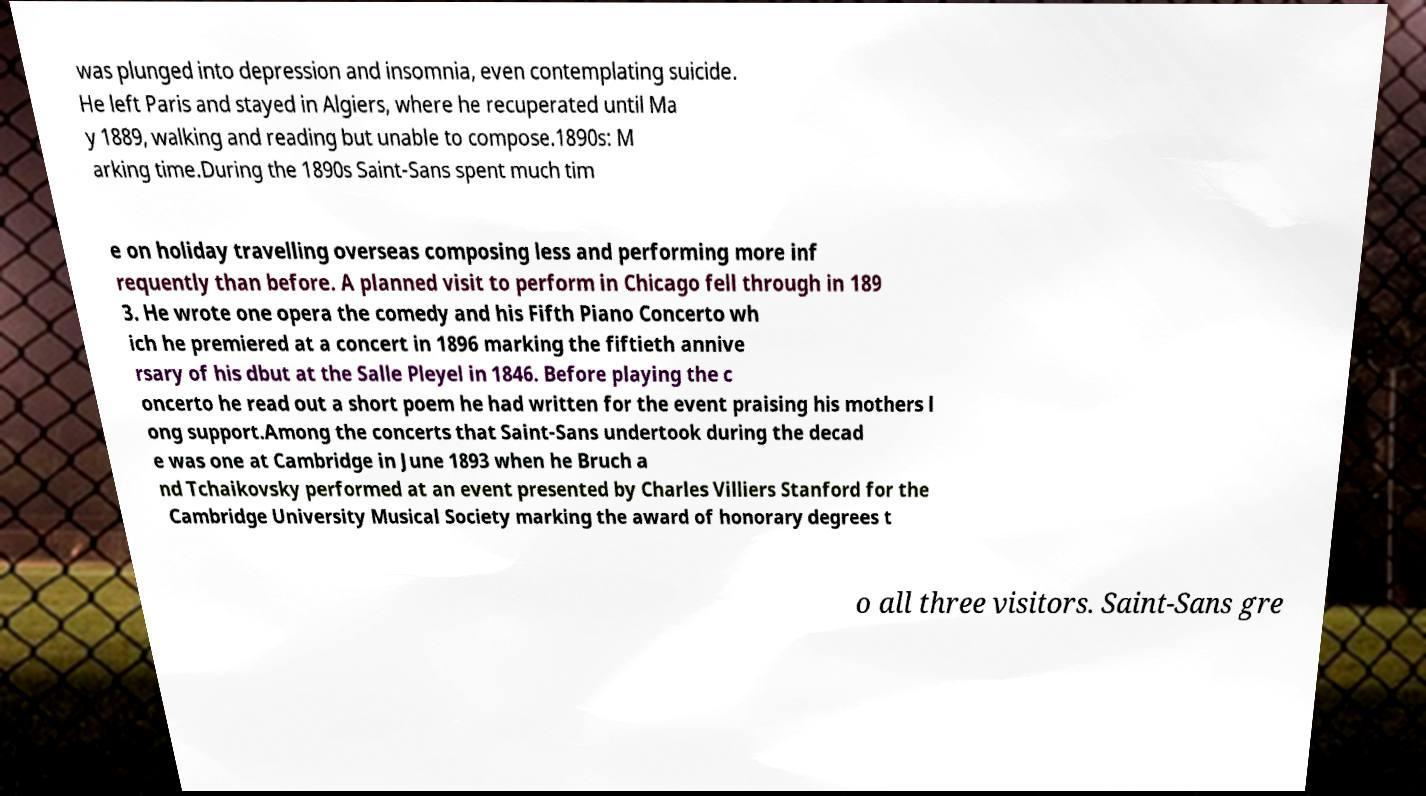Please identify and transcribe the text found in this image. was plunged into depression and insomnia, even contemplating suicide. He left Paris and stayed in Algiers, where he recuperated until Ma y 1889, walking and reading but unable to compose.1890s: M arking time.During the 1890s Saint-Sans spent much tim e on holiday travelling overseas composing less and performing more inf requently than before. A planned visit to perform in Chicago fell through in 189 3. He wrote one opera the comedy and his Fifth Piano Concerto wh ich he premiered at a concert in 1896 marking the fiftieth annive rsary of his dbut at the Salle Pleyel in 1846. Before playing the c oncerto he read out a short poem he had written for the event praising his mothers l ong support.Among the concerts that Saint-Sans undertook during the decad e was one at Cambridge in June 1893 when he Bruch a nd Tchaikovsky performed at an event presented by Charles Villiers Stanford for the Cambridge University Musical Society marking the award of honorary degrees t o all three visitors. Saint-Sans gre 